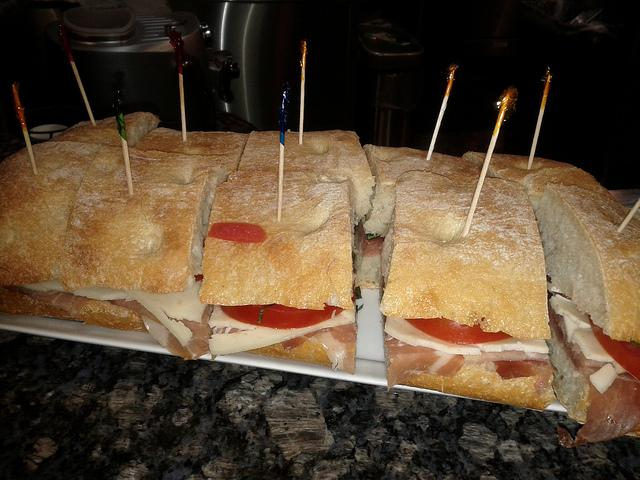What is being used to keep the sandwiches from falling apart?

Choices:
A) tape
B) knives
C) toothpicks
D) glue toothpicks 